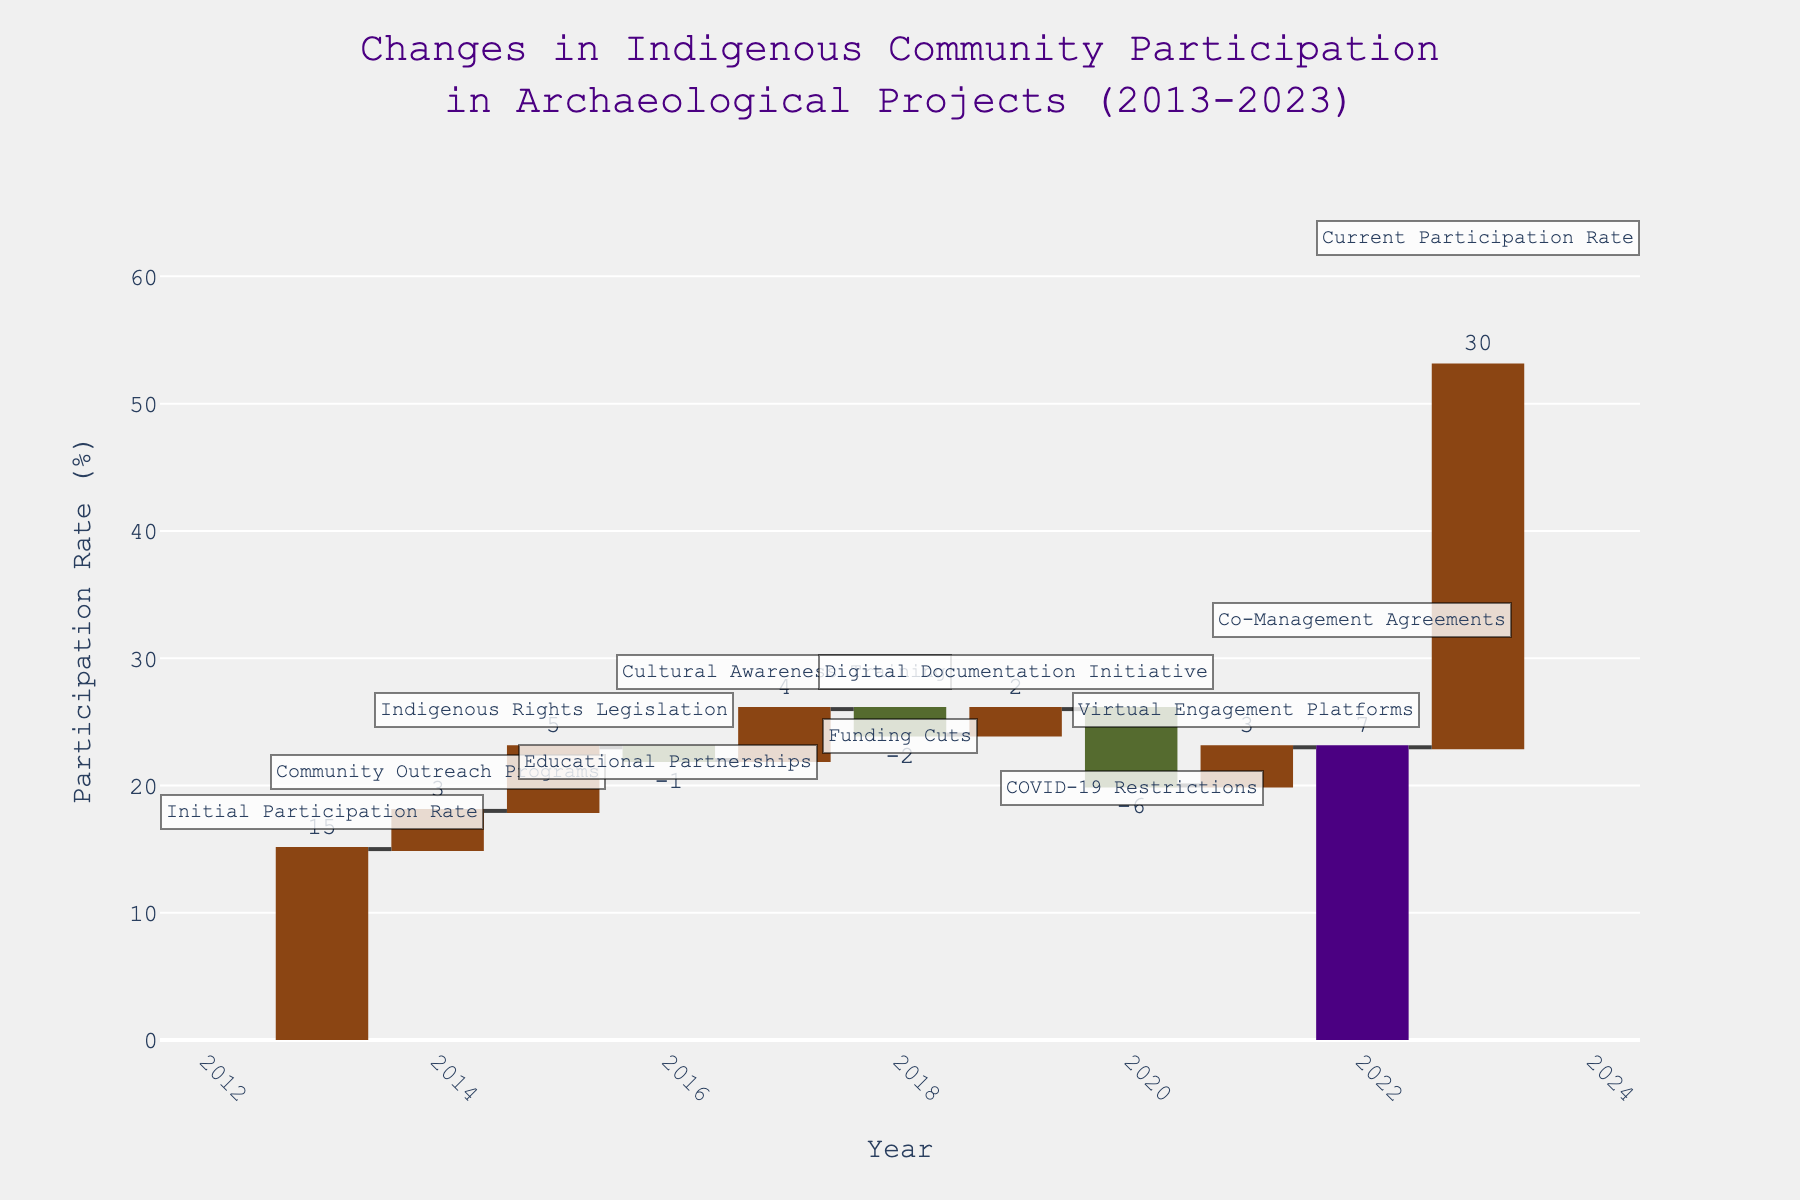What is the initial participation rate in archaeological projects in 2013? The initial participation rate for 2013 is explicitly mentioned at the start of the waterfall chart.
Answer: 15% What event in 2014 led to an increase in the participation rate, and by how much did it increase? According to the waterfall chart, "Community Outreach Programs" in 2014 led to an increase in the participation rate by +3 units.
Answer: Community Outreach Programs, +3% What is the total change in the participation rate from 2018 to 2020? In 2018, there was a decrease of -2 due to "Funding Cuts". In 2019, an increase of +2 from the "Digital Documentation Initiative" nullified that decrease. In 2020, there was a significant drop of -6 due to "COVID-19 Restrictions". Adding these changes together, -2 + 2 - 6 results in a net change of -6.
Answer: -6% How did the "Educational Partnerships" in 2016 affect the participation rate? The "Educational Partnerships" in 2016 caused a decrease in the participation rate by -1 unit in the waterfall chart.
Answer: -1% Which year saw the highest positive impact on the participation rate, and what was the percentage increase? In 2022, "Co-Management Agreements" led to the highest positive impact with an increase of +7 units in participation rate.
Answer: 2022, +7% What is the difference in participation rates between the highest and lowest yearly changes? The highest yearly increase was +7 (in 2022), and the lowest was -6 (in 2020). The difference between them is 7 - 6 = 13.
Answer: 13% How did "Virtual Engagement Platforms" in 2021 impact the participation rate? "Virtual Engagement Platforms" in 2021 increased the participation rate by +3 units.
Answer: +3% Given the factors listed, was the cumulative effect of changes between 2014 and 2017 positive or negative? Positive. Summing up the individual changes: +3 (2014) + 5 (2015) - 1 (2016) + 4 (2017) results in a cumulative positive change of +11 units.
Answer: Positive What is the participation rate in archaeological projects in 2023? The participation rate in 2023 is indicated as the "Current Participation Rate" in the waterfall chart.
Answer: 30% If there hadn't been funding cuts in 2018, what would have been the participation rate by 2019? Without the -2 from the funding cuts in 2018, the total increase from 2013 to 2019 would be the sum of +3 (2014) + 5 (2015) - 1 (2016) + 4 (2017) + 0 (2018 without cuts) + 2 (2019) + 15 (initial rate) = 28 units instead of 26.
Answer: 28% 